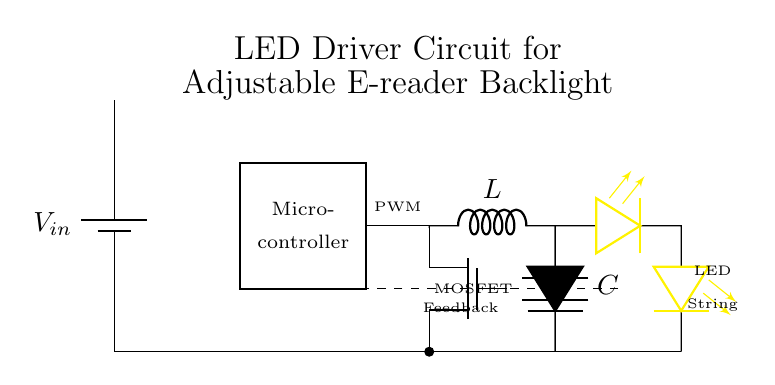What is the power source for this circuit? The power source is represented by the battery symbol labeled as V-in at the top left of the diagram, which provides the necessary voltage to the circuit.
Answer: V-in What type of transistor is used in this circuit? The circuit uses a MOSFET, identified by the symbol Tnmos, that is positioned below the PWM output and is responsible for regulating the power to the LED string.
Answer: MOSFET How many LEDs are in the string shown in the circuit? The circuit diagram shows a series connection of two LED symbols (leDo), indicating that there are two LEDs in the string depicted.
Answer: Two What is the purpose of the inductor in this circuit? The inductor, marked with L, is used to store energy and helps smooth out the current flowing to the LED string, which is essential for generating a steady backlight illumination.
Answer: Energy storage What does the dashed line represent in the LED driver circuit? The dashed line indicates a feedback signal that likely monitors or regulates the current or voltage in the LED circuit, allowing the microcontroller to adjust the PWM signal accordingly.
Answer: Feedback signal What is the role of the capacitor in this circuit? The capacitor, labeled C, is responsible for filtering and stabilizing the voltage across the LED string, ensuring consistent brightness and preventing flickering during operation.
Answer: Voltage stabilization 